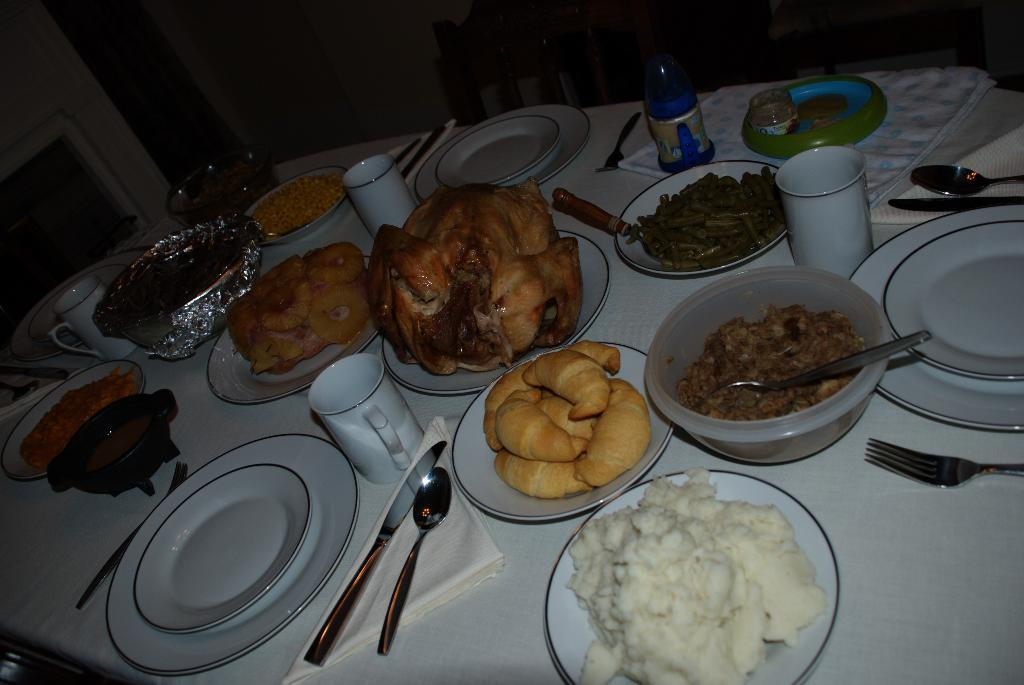What type of objects can be seen in the image? There are food items, forks, spoons, and glasses in the image. What might be used for eating the food items? Forks and spoons can be used for eating the food items. What might be used for drinking in the image? Glasses can be used for drinking. Where are the objects located in the image? The objects are on a dining table. What else can be seen in the image? Chairs are visible at the top of the image. What type of brass instrument can be seen being played in the image? There is no brass instrument present in the image; it features food items, forks, spoons, glasses, and chairs. What type of chalk is used to draw on the table in the image? There is no chalk or drawing on the table in the image. 